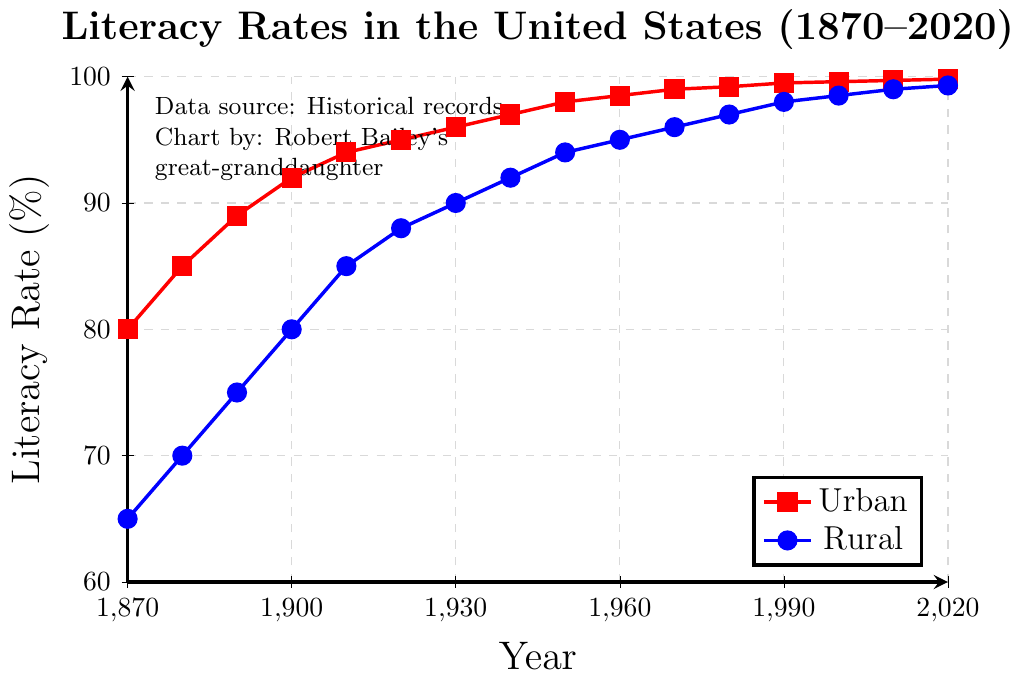What was the literacy rate in urban areas in 1900? The figure shows a red line with a square marker representing urban literacy rates. Locating 1900 on the x-axis and following the corresponding y-axis value for the red line gives the literacy rate.
Answer: 92% What is the difference between urban and rural literacy rates in 1870? In 1870, the literacy rate for urban areas (red line) is 80, and for rural areas (blue line) is 65. Subtracting 65 from 80 gives the difference.
Answer: 15% How did the rural literacy rate change between 1920 and 1940? In 1920, the rural literacy rate (blue line) is 88, and in 1940 it is 92. Subtracting 88 from 92 gives the change.
Answer: 4% Which year had the smallest gap between urban and rural literacy rates? By visually inspecting the distance between the red and blue lines across the years, the smallest gap appears around 2010, where the urban rate is 99.7 and the rural rate is 99.
Answer: 2010 What was the average literacy rate in rural areas from 1910 to 1930? The rural literacy rates for 1910, 1920, and 1930 are 85, 88, and 90, respectively. Summing these values and dividing by the number of years (3) gives the average: (85 + 88 + 90) / 3 = 87.67.
Answer: 87.67% By how much did the urban literacy rate increase from 1870 to 2020? The urban literacy rate in 1870 is 80, and in 2020 it is 99.8. Subtracting 80 from 99.8 gives the increase.
Answer: 19.8% Which area had a literacy rate of 90% first, urban or rural? The figure shows that the urban area's literacy rate (red line) reached 90% in 1890, while the rural area's literacy rate (blue line) reached 90% in 1930.
Answer: Urban Compare the trend of literacy rate growth in urban vs rural areas from 1870 to 2020. The trend shows that both urban (red line) and rural (blue line) literacy rates rise consistently over time, but the urban rate increases more rapidly initially. The gap between urban and rural rates narrows significantly after the mid-20th century.
Answer: Urban rate grows faster initially, gap narrows later By how much did the difference between urban and rural literacy rates decrease from 1880 to 1980? In 1880, the difference was 85 (urban) - 70 (rural) = 15. In 1980, the difference was 99.2 (urban) - 97 (rural) = 2.2. The decrease in difference is 15 - 2.2 = 12.8.
Answer: 12.8% What is the visual difference in the plot between urban and rural literacy data points? Urban literacy data points are represented by a red line with square markers, while rural data points are shown with a blue line and circular markers.
Answer: Red squares vs blue circles 